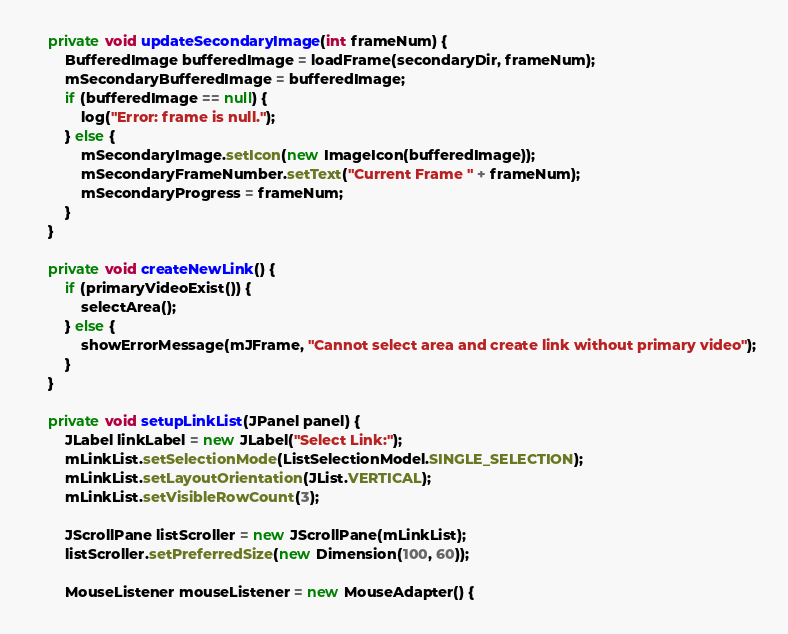Convert code to text. <code><loc_0><loc_0><loc_500><loc_500><_Java_>
    private void updateSecondaryImage(int frameNum) {
        BufferedImage bufferedImage = loadFrame(secondaryDir, frameNum);
        mSecondaryBufferedImage = bufferedImage;
        if (bufferedImage == null) {
            log("Error: frame is null.");
        } else {
            mSecondaryImage.setIcon(new ImageIcon(bufferedImage));
            mSecondaryFrameNumber.setText("Current Frame " + frameNum);
            mSecondaryProgress = frameNum;
        }
    }

    private void createNewLink() {
        if (primaryVideoExist()) {
            selectArea();
        } else {
            showErrorMessage(mJFrame, "Cannot select area and create link without primary video");
        }
    }

    private void setupLinkList(JPanel panel) {
        JLabel linkLabel = new JLabel("Select Link:");
        mLinkList.setSelectionMode(ListSelectionModel.SINGLE_SELECTION);
        mLinkList.setLayoutOrientation(JList.VERTICAL);
        mLinkList.setVisibleRowCount(3);

        JScrollPane listScroller = new JScrollPane(mLinkList);
        listScroller.setPreferredSize(new Dimension(100, 60));

        MouseListener mouseListener = new MouseAdapter() {</code> 